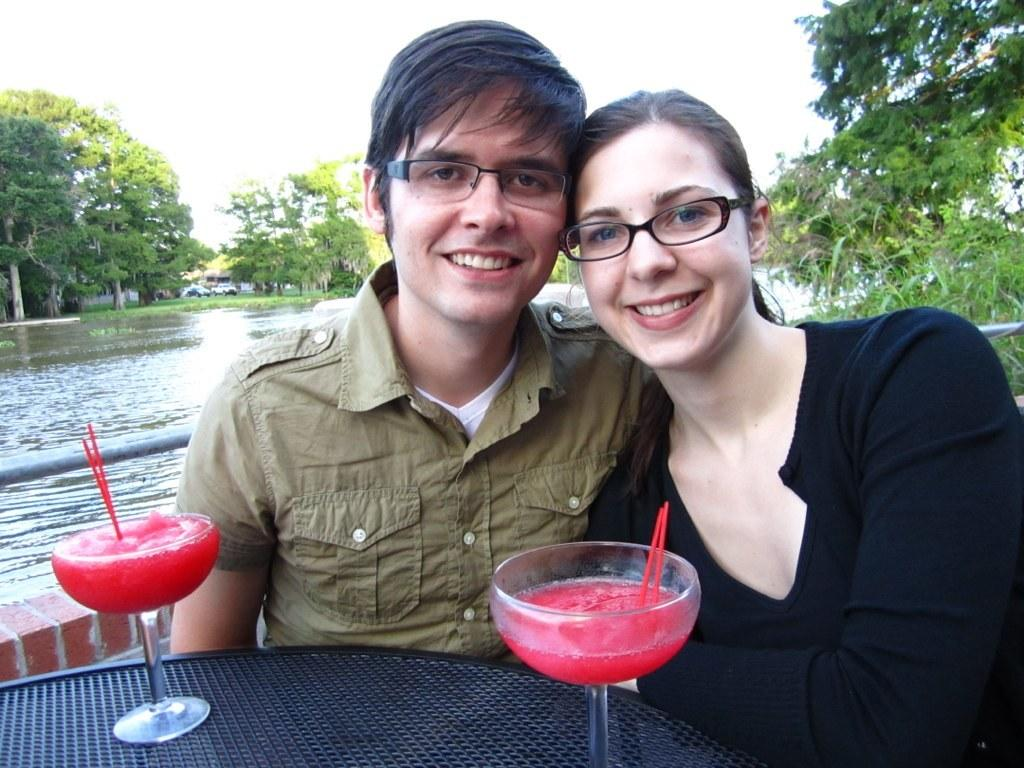Who can be seen in the foreground of the image? There is a man and a woman in the foreground of the image. What are they doing in the image? They are sitting in front of a table. What objects are on the table? There are two glasses on the table. What can be seen in the background of the image? Water, trees, and the sky are visible in the background of the image. What type of skin condition can be seen on the woman's face in the image? There is no indication of any skin condition on the woman's face in the image. What musical harmony can be heard in the background of the image? There is no audio or music present in the image, so it's not possible to determine any musical harmony. 